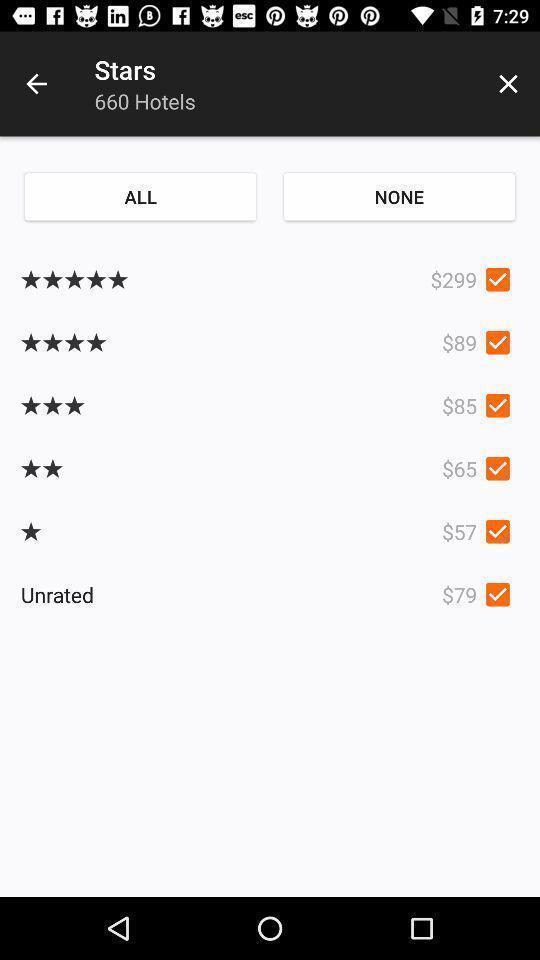What can you discern from this picture? Page showing the reviews of hotels. 